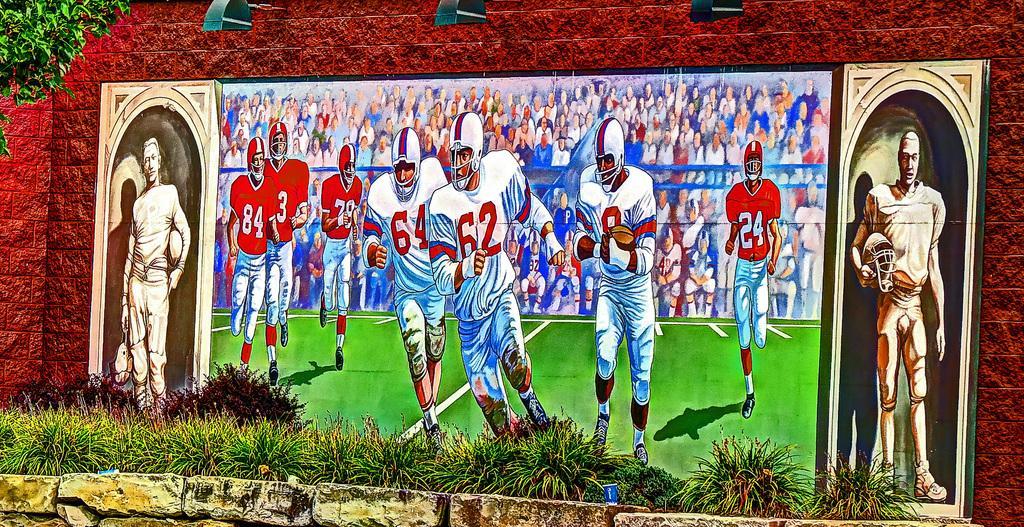Describe this image in one or two sentences. In this picture we see a painting of football players in front of a red brick wall with a grass surface. 